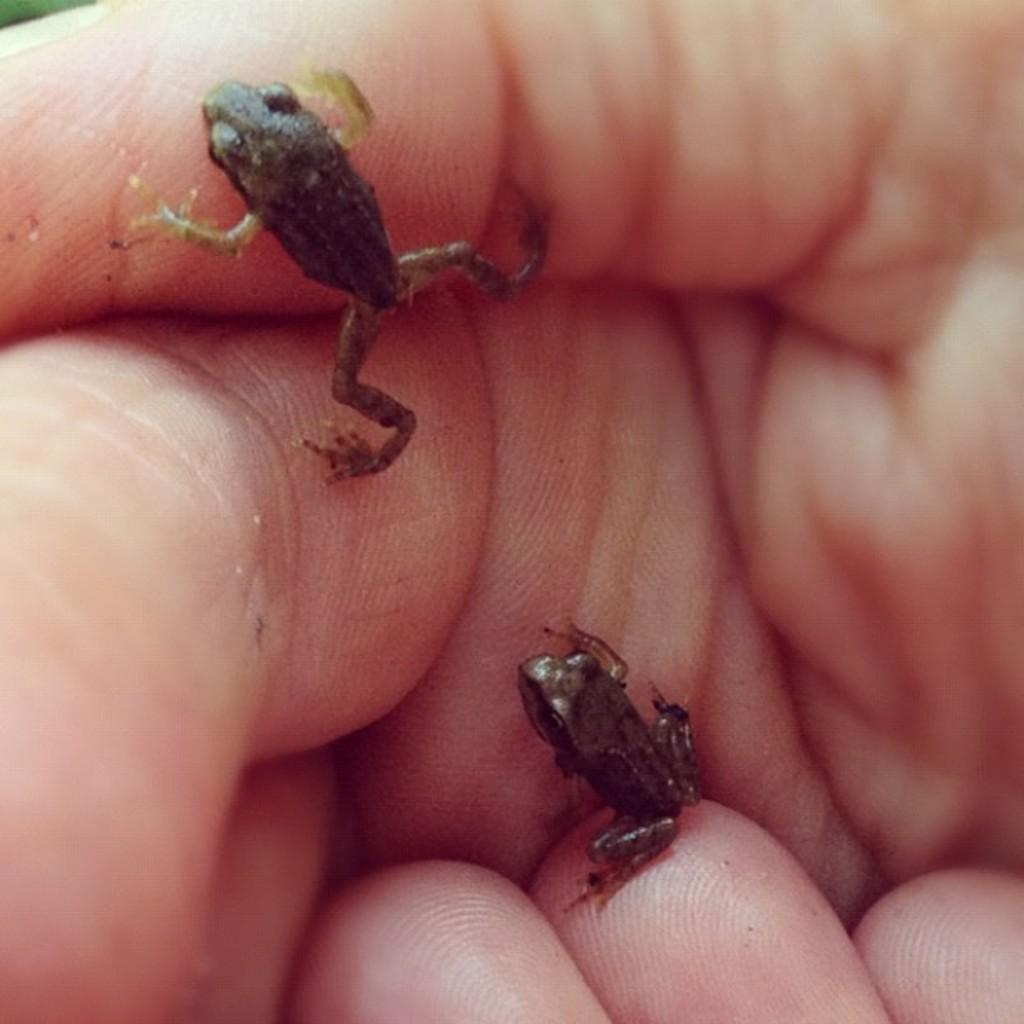What animals are present in the image? There are two frogs in the image. Where are the frogs located? The frogs are on a person's hand. Can you describe the other hand visible in the image? There is another hand visible at the bottom of the image. What type of sofa can be seen in the background of the image? There is no sofa present in the image; it features two frogs on a person's hand and another hand at the bottom. 